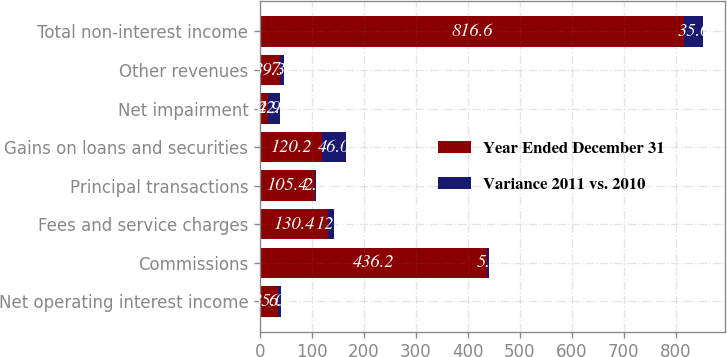Convert chart to OTSL. <chart><loc_0><loc_0><loc_500><loc_500><stacked_bar_chart><ecel><fcel>Net operating interest income<fcel>Commissions<fcel>Fees and service charges<fcel>Principal transactions<fcel>Gains on loans and securities<fcel>Net impairment<fcel>Other revenues<fcel>Total non-interest income<nl><fcel>Year Ended December 31<fcel>35<fcel>436.2<fcel>130.4<fcel>105.4<fcel>120.2<fcel>14.9<fcel>39.3<fcel>816.6<nl><fcel>Variance 2011 vs. 2010<fcel>6.3<fcel>5.2<fcel>12<fcel>2<fcel>46<fcel>22.8<fcel>7<fcel>35<nl></chart> 